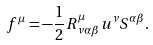Convert formula to latex. <formula><loc_0><loc_0><loc_500><loc_500>f ^ { \mu } = - \frac { 1 } { 2 } R _ { \, \nu \alpha \beta } ^ { \mu } u ^ { \nu } S ^ { \alpha \beta } .</formula> 